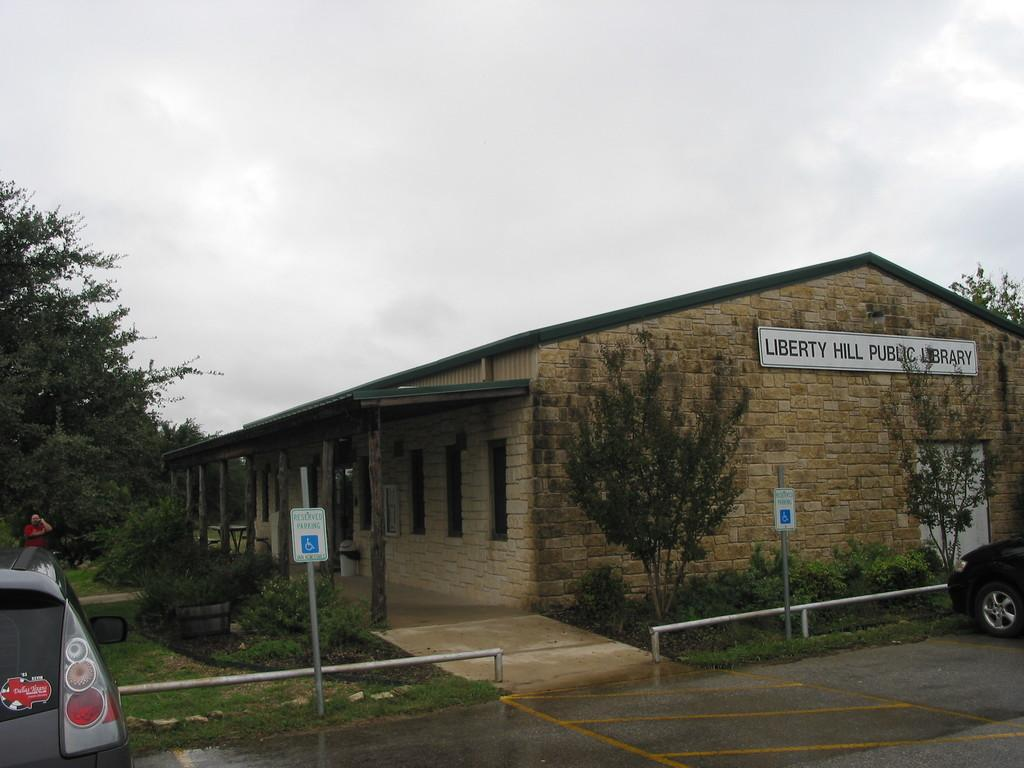What is the main subject in the center of the image? There is a building and trees in the center of the image. What can be seen on the left side of the image? There is a person, a car, a sign board, and trees on the left side of the image. What is visible in the background of the image? The sky is visible in the background of the image. What type of canvas is being smashed by the person in the image? There is no canvas or smashing action present in the image. What is the person's hope for the future in the image? There is no indication of the person's hopes or future in the image. 